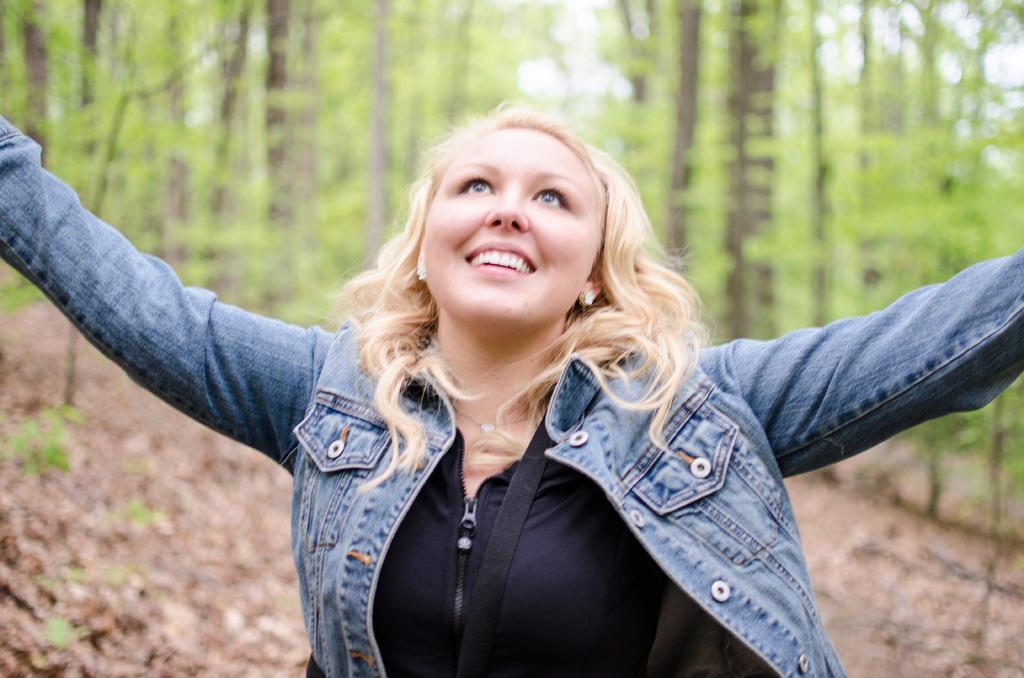What is the main subject of the image? There is a person in the image. What is the person's facial expression? The person is smiling. What can be seen in the background of the image? There are trees in the background of the image. What type of prose is the person reading in the image? There is no indication in the image that the person is reading any prose. 